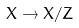Convert formula to latex. <formula><loc_0><loc_0><loc_500><loc_500>X \rightarrow X / Z</formula> 